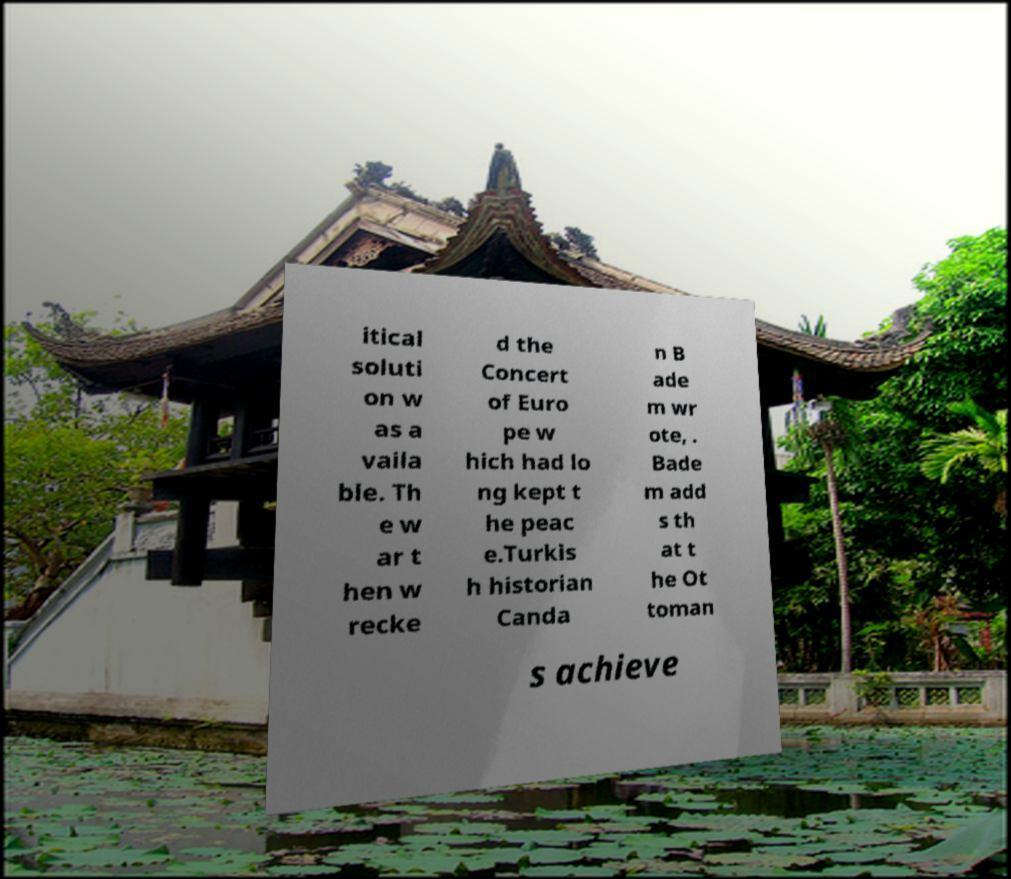Can you accurately transcribe the text from the provided image for me? itical soluti on w as a vaila ble. Th e w ar t hen w recke d the Concert of Euro pe w hich had lo ng kept t he peac e.Turkis h historian Canda n B ade m wr ote, . Bade m add s th at t he Ot toman s achieve 